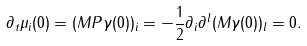<formula> <loc_0><loc_0><loc_500><loc_500>\partial _ { t } \mu _ { i } ( 0 ) = ( M P \gamma ( 0 ) ) _ { i } = - \frac { 1 } { 2 } \partial _ { i } \partial ^ { l } ( M \gamma ( 0 ) ) _ { l } = 0 .</formula> 